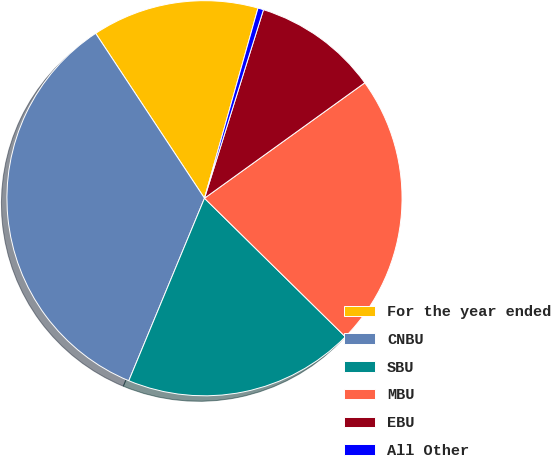<chart> <loc_0><loc_0><loc_500><loc_500><pie_chart><fcel>For the year ended<fcel>CNBU<fcel>SBU<fcel>MBU<fcel>EBU<fcel>All Other<nl><fcel>13.65%<fcel>34.46%<fcel>18.89%<fcel>22.3%<fcel>10.24%<fcel>0.46%<nl></chart> 